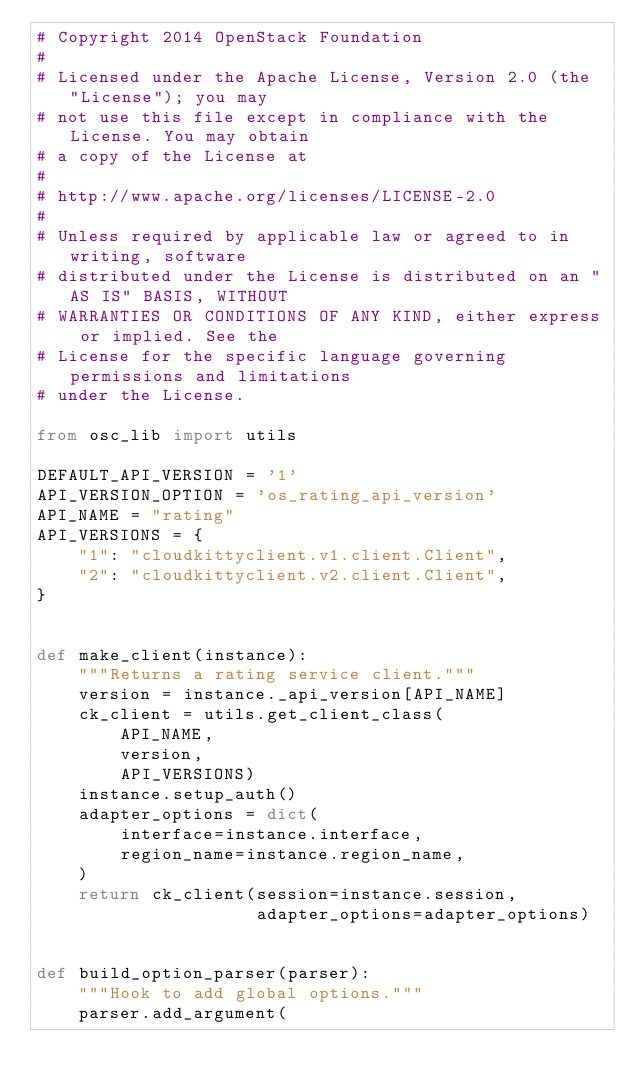<code> <loc_0><loc_0><loc_500><loc_500><_Python_># Copyright 2014 OpenStack Foundation
#
# Licensed under the Apache License, Version 2.0 (the "License"); you may
# not use this file except in compliance with the License. You may obtain
# a copy of the License at
#
# http://www.apache.org/licenses/LICENSE-2.0
#
# Unless required by applicable law or agreed to in writing, software
# distributed under the License is distributed on an "AS IS" BASIS, WITHOUT
# WARRANTIES OR CONDITIONS OF ANY KIND, either express or implied. See the
# License for the specific language governing permissions and limitations
# under the License.

from osc_lib import utils

DEFAULT_API_VERSION = '1'
API_VERSION_OPTION = 'os_rating_api_version'
API_NAME = "rating"
API_VERSIONS = {
    "1": "cloudkittyclient.v1.client.Client",
    "2": "cloudkittyclient.v2.client.Client",
}


def make_client(instance):
    """Returns a rating service client."""
    version = instance._api_version[API_NAME]
    ck_client = utils.get_client_class(
        API_NAME,
        version,
        API_VERSIONS)
    instance.setup_auth()
    adapter_options = dict(
        interface=instance.interface,
        region_name=instance.region_name,
    )
    return ck_client(session=instance.session,
                     adapter_options=adapter_options)


def build_option_parser(parser):
    """Hook to add global options."""
    parser.add_argument(</code> 